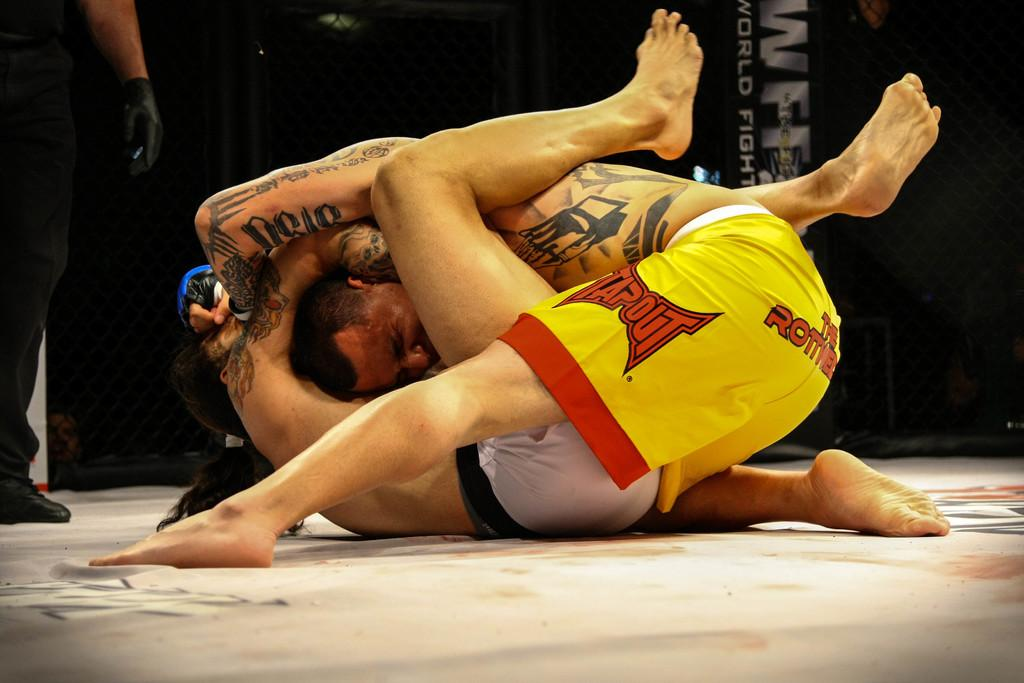<image>
Give a short and clear explanation of the subsequent image. Two men wrestling on the ground, one of whom has the word Tapout on his shorts. 